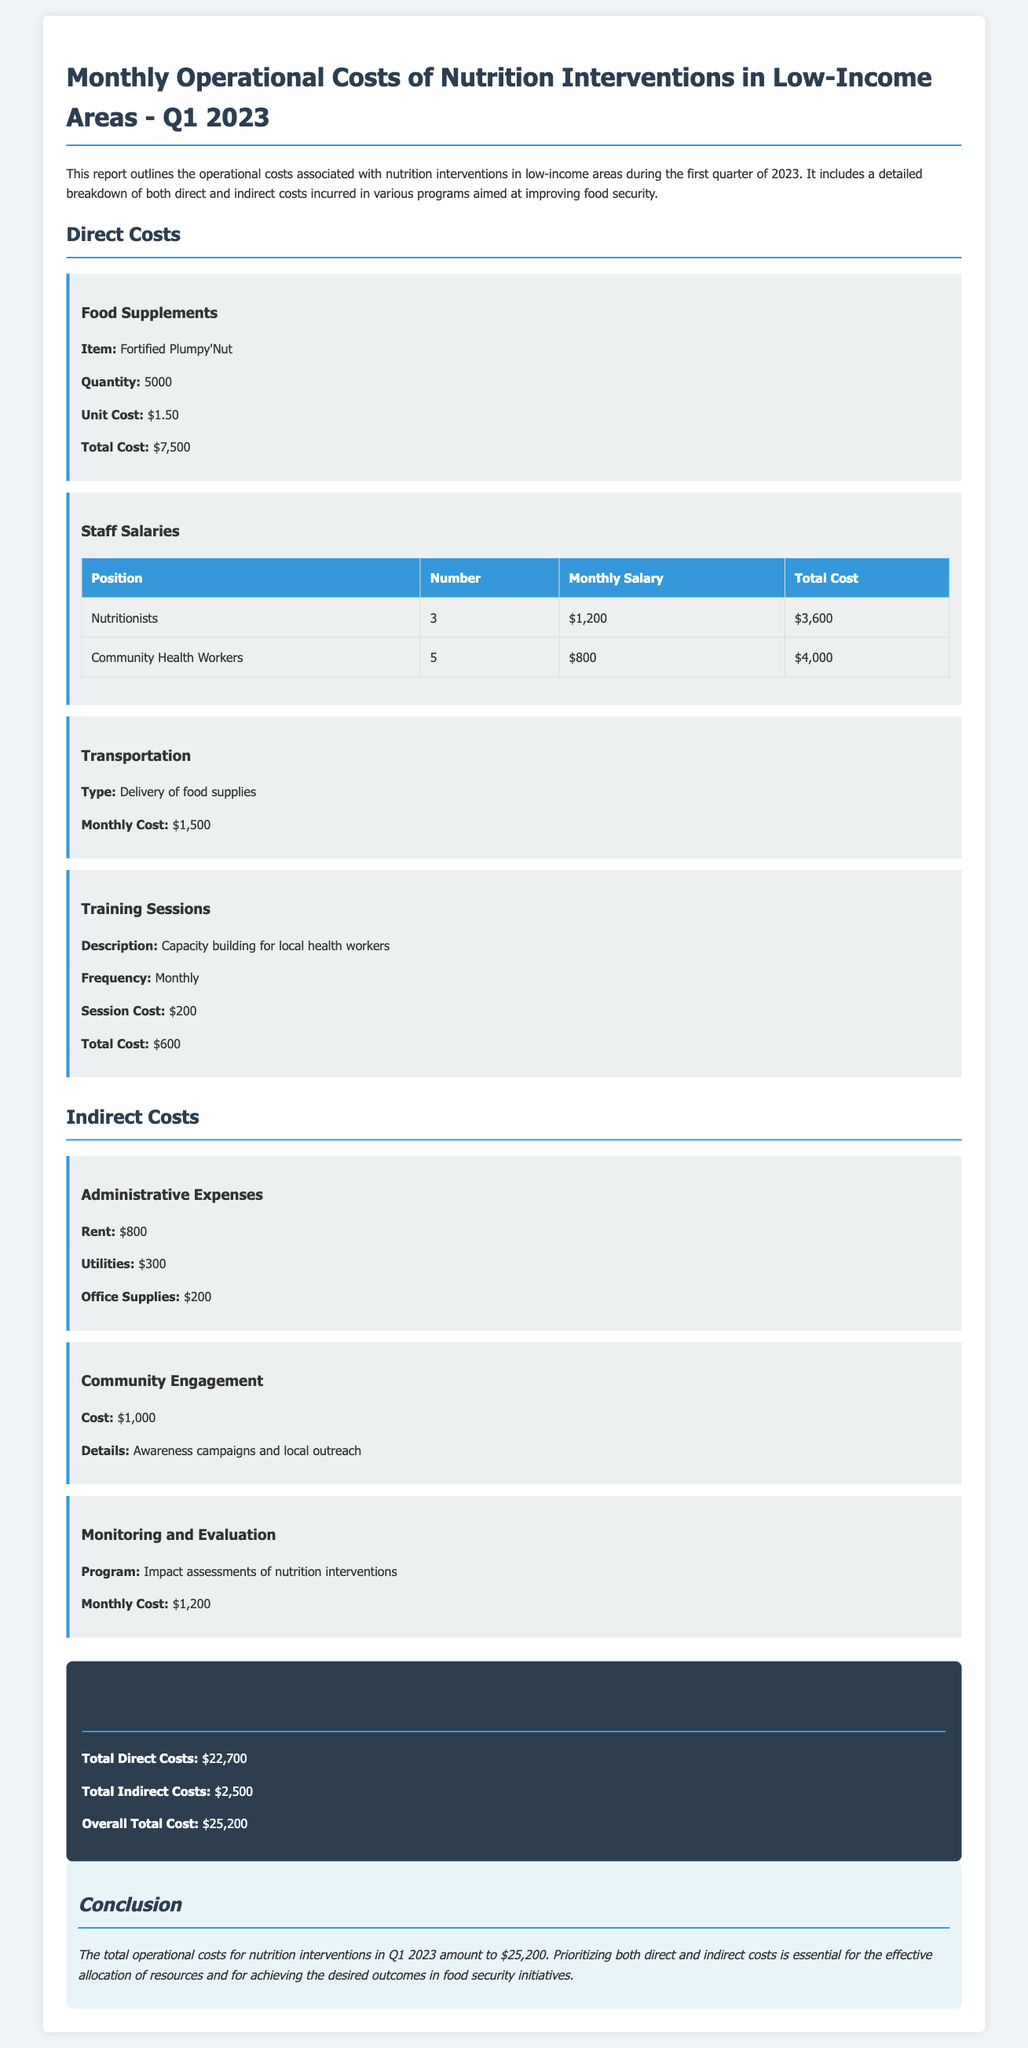what is the total cost of food supplements? The total cost of food supplements is listed as $7,500 in the report.
Answer: $7,500 how many nutritionists are employed? The report states that there are 3 nutritionists employed.
Answer: 3 what is the monthly cost for transportation? The monthly cost for transportation related to the delivery of food supplies is provided as $1,500.
Answer: $1,500 what is the total cost of direct costs? The total direct costs are calculated as $22,700, as shown in the total cost summary.
Answer: $22,700 what are the administrative expenses for rent? The rent expense listed under administrative expenses is $800.
Answer: $800 how often are the training sessions conducted? The training sessions are conducted monthly, as mentioned in the cost section.
Answer: Monthly what is the total number of community health workers? The report indicates that there are 5 community health workers.
Answer: 5 what is the overall total cost of nutrition interventions? The overall total cost of nutrition interventions is summarized as $25,200 in the report.
Answer: $25,200 what is the cost for community engagement? The cost for community engagement is documented as $1,000 for awareness campaigns and local outreach.
Answer: $1,000 